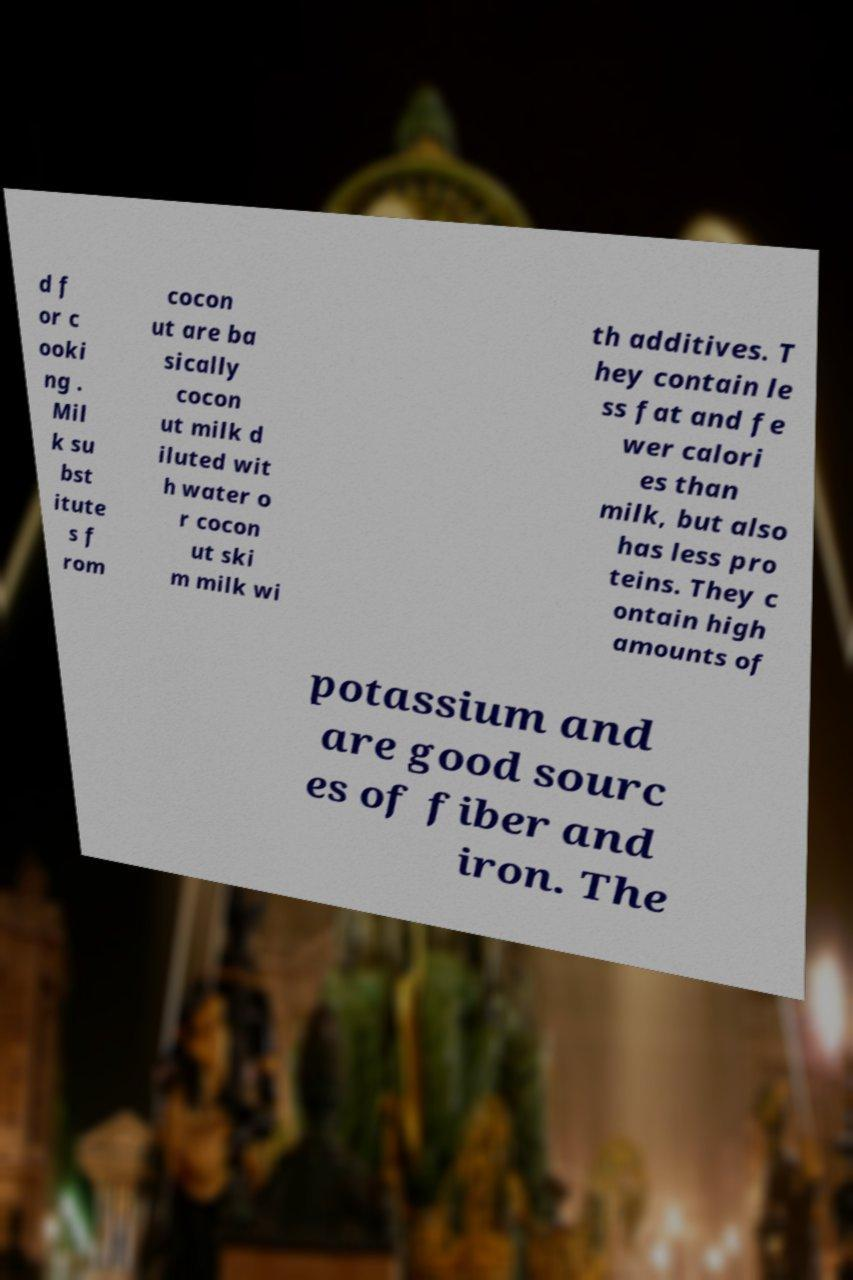Can you accurately transcribe the text from the provided image for me? d f or c ooki ng . Mil k su bst itute s f rom cocon ut are ba sically cocon ut milk d iluted wit h water o r cocon ut ski m milk wi th additives. T hey contain le ss fat and fe wer calori es than milk, but also has less pro teins. They c ontain high amounts of potassium and are good sourc es of fiber and iron. The 